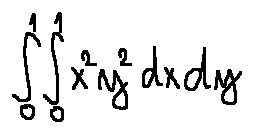Convert formula to latex. <formula><loc_0><loc_0><loc_500><loc_500>\int \lim i t s _ { 0 } ^ { 1 } \int \lim i t s _ { 0 } ^ { 1 } x ^ { 2 } y ^ { 2 } d x d y</formula> 